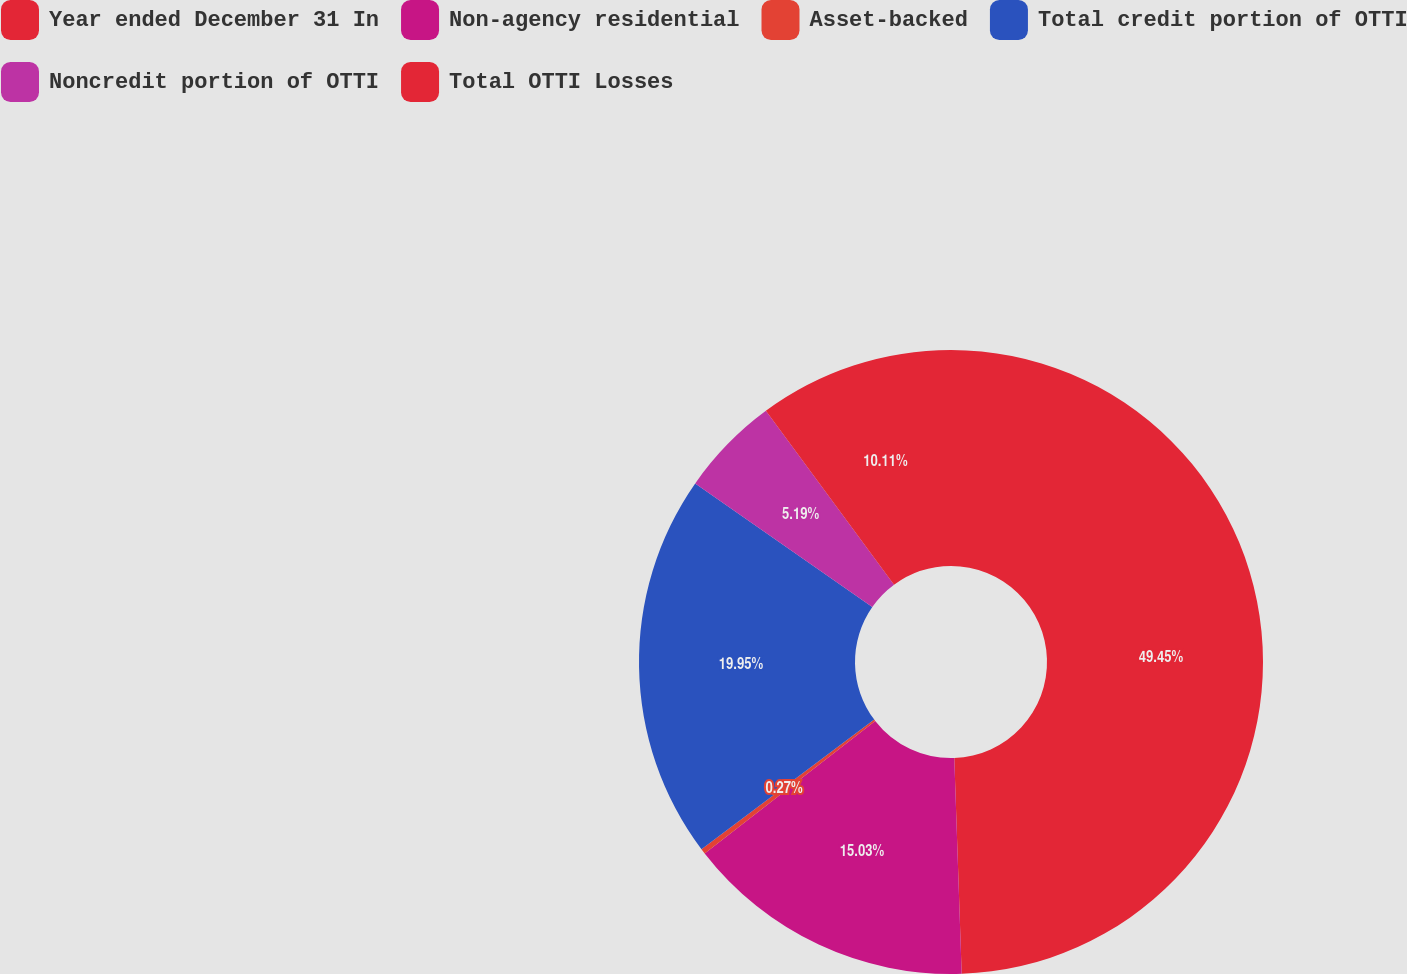Convert chart. <chart><loc_0><loc_0><loc_500><loc_500><pie_chart><fcel>Year ended December 31 In<fcel>Non-agency residential<fcel>Asset-backed<fcel>Total credit portion of OTTI<fcel>Noncredit portion of OTTI<fcel>Total OTTI Losses<nl><fcel>49.46%<fcel>15.03%<fcel>0.27%<fcel>19.95%<fcel>5.19%<fcel>10.11%<nl></chart> 